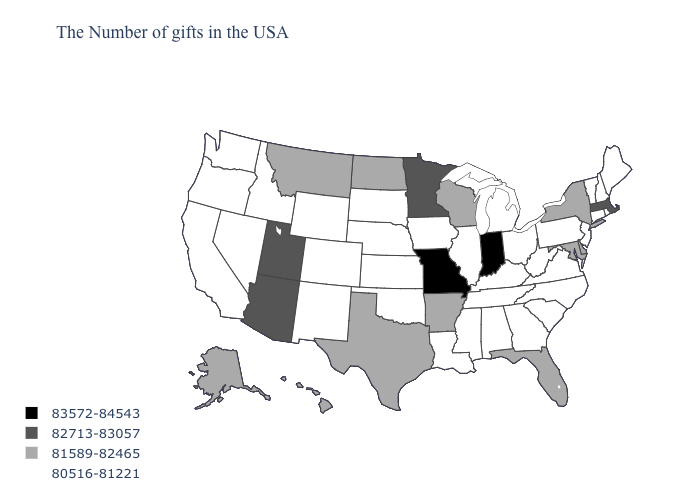What is the value of Washington?
Answer briefly. 80516-81221. What is the lowest value in the USA?
Answer briefly. 80516-81221. What is the highest value in the USA?
Write a very short answer. 83572-84543. Does South Carolina have the lowest value in the USA?
Give a very brief answer. Yes. Does Missouri have the highest value in the USA?
Write a very short answer. Yes. Does Ohio have the highest value in the USA?
Answer briefly. No. What is the value of Iowa?
Short answer required. 80516-81221. What is the value of Louisiana?
Concise answer only. 80516-81221. Among the states that border Alabama , which have the highest value?
Give a very brief answer. Florida. Among the states that border Kentucky , which have the lowest value?
Keep it brief. Virginia, West Virginia, Ohio, Tennessee, Illinois. What is the value of Vermont?
Answer briefly. 80516-81221. What is the value of Missouri?
Short answer required. 83572-84543. Does Virginia have the same value as California?
Keep it brief. Yes. What is the lowest value in states that border North Carolina?
Write a very short answer. 80516-81221. Does the first symbol in the legend represent the smallest category?
Short answer required. No. 